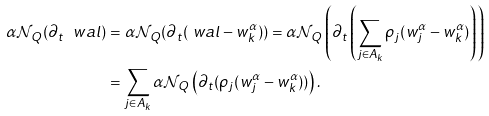<formula> <loc_0><loc_0><loc_500><loc_500>\alpha \mathcal { N } _ { Q } ( \partial _ { t } \ w a l ) & = \alpha \mathcal { N } _ { Q } ( \partial _ { t } ( \ w a l - w ^ { \alpha } _ { k } ) ) = \alpha \mathcal { N } _ { Q } \left ( \partial _ { t } \left ( \sum _ { j \in A _ { k } } \rho _ { j } ( w ^ { \alpha } _ { j } - w ^ { \alpha } _ { k } ) \right ) \right ) \\ & = \sum _ { j \in A _ { k } } \alpha \mathcal { N } _ { Q } \left ( \partial _ { t } ( \rho _ { j } ( w ^ { \alpha } _ { j } - w ^ { \alpha } _ { k } ) ) \right ) .</formula> 